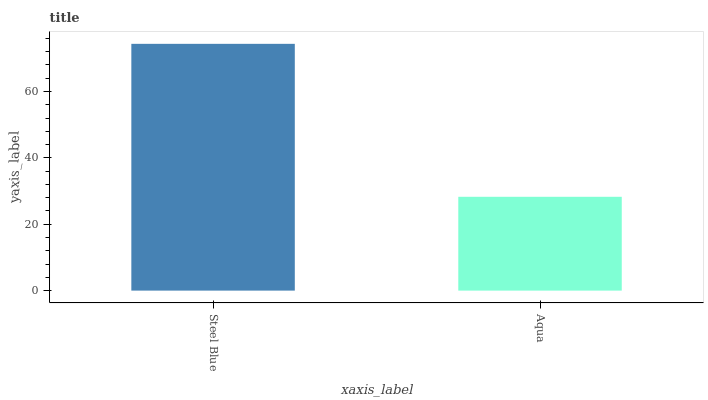Is Aqua the minimum?
Answer yes or no. Yes. Is Steel Blue the maximum?
Answer yes or no. Yes. Is Aqua the maximum?
Answer yes or no. No. Is Steel Blue greater than Aqua?
Answer yes or no. Yes. Is Aqua less than Steel Blue?
Answer yes or no. Yes. Is Aqua greater than Steel Blue?
Answer yes or no. No. Is Steel Blue less than Aqua?
Answer yes or no. No. Is Steel Blue the high median?
Answer yes or no. Yes. Is Aqua the low median?
Answer yes or no. Yes. Is Aqua the high median?
Answer yes or no. No. Is Steel Blue the low median?
Answer yes or no. No. 